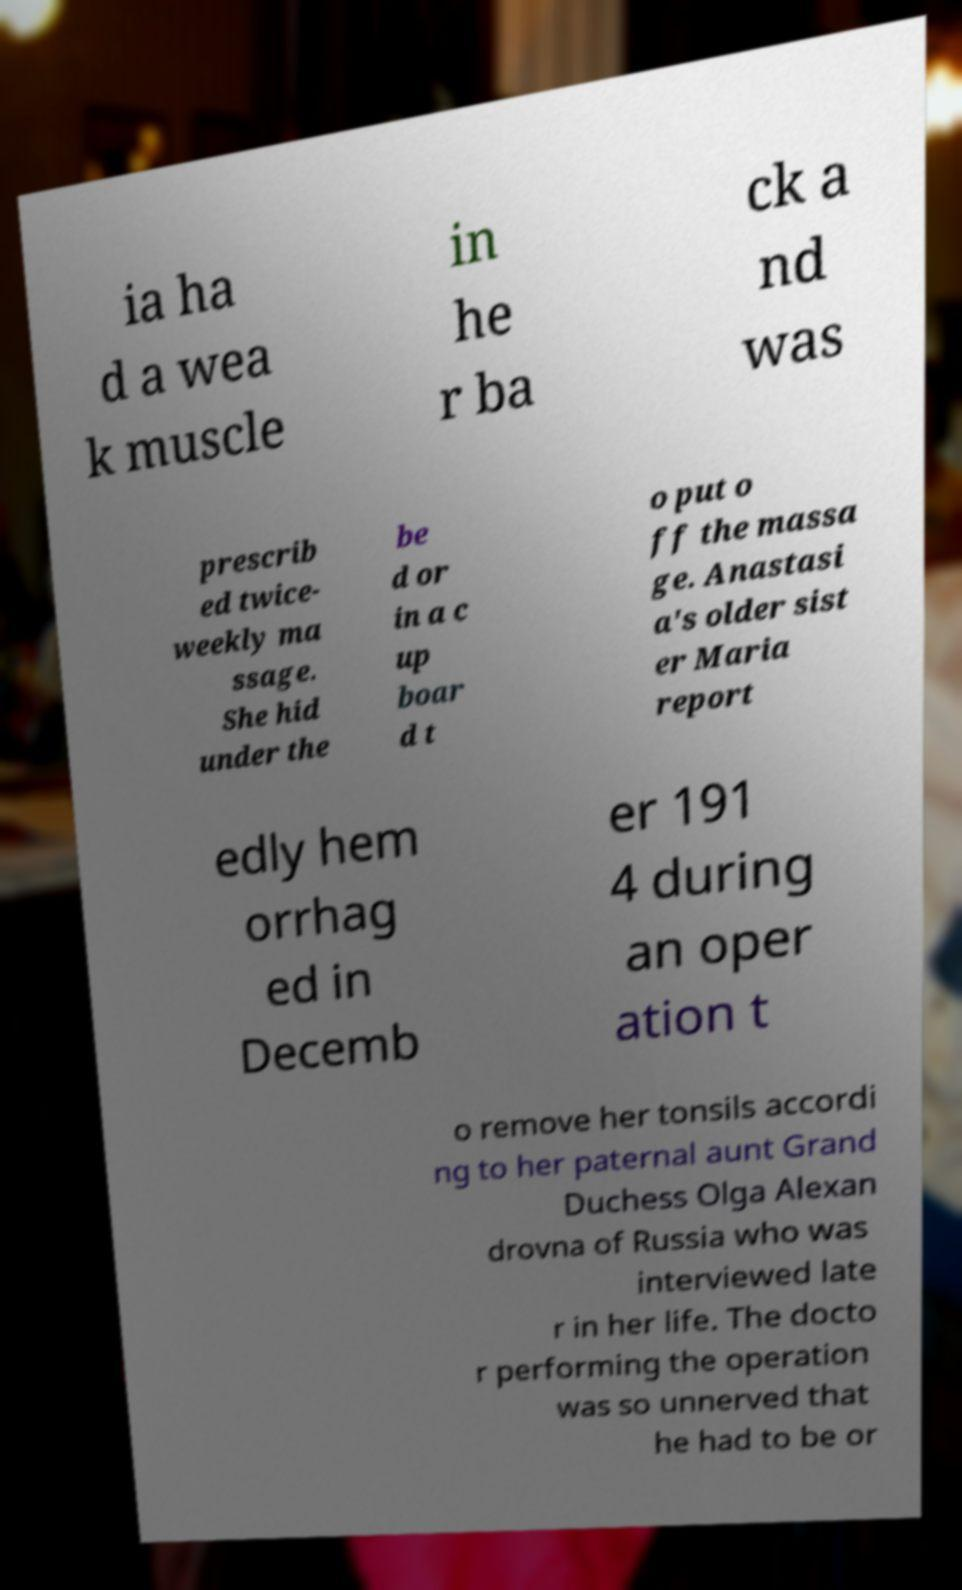Can you read and provide the text displayed in the image?This photo seems to have some interesting text. Can you extract and type it out for me? ia ha d a wea k muscle in he r ba ck a nd was prescrib ed twice- weekly ma ssage. She hid under the be d or in a c up boar d t o put o ff the massa ge. Anastasi a's older sist er Maria report edly hem orrhag ed in Decemb er 191 4 during an oper ation t o remove her tonsils accordi ng to her paternal aunt Grand Duchess Olga Alexan drovna of Russia who was interviewed late r in her life. The docto r performing the operation was so unnerved that he had to be or 